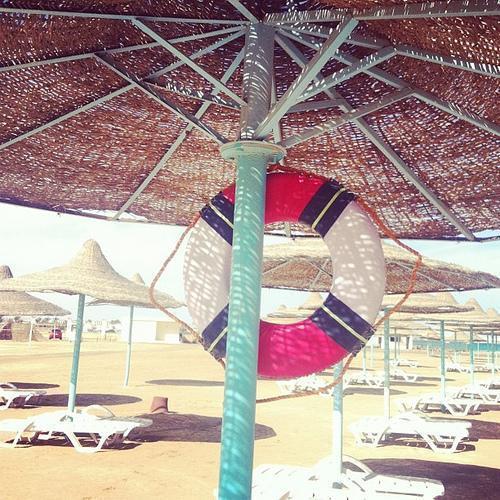How many life rafts are there?
Give a very brief answer. 1. 